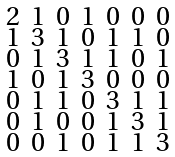Convert formula to latex. <formula><loc_0><loc_0><loc_500><loc_500>\begin{smallmatrix} 2 & 1 & 0 & 1 & 0 & 0 & 0 \\ 1 & 3 & 1 & 0 & 1 & 1 & 0 \\ 0 & 1 & 3 & 1 & 1 & 0 & 1 \\ 1 & 0 & 1 & 3 & 0 & 0 & 0 \\ 0 & 1 & 1 & 0 & 3 & 1 & 1 \\ 0 & 1 & 0 & 0 & 1 & 3 & 1 \\ 0 & 0 & 1 & 0 & 1 & 1 & 3 \end{smallmatrix}</formula> 